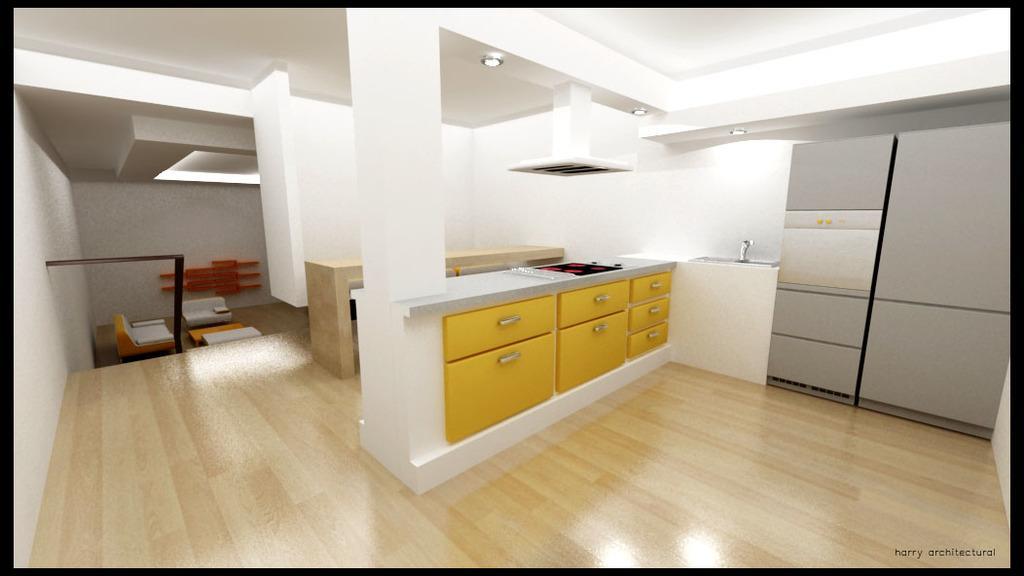Could you give a brief overview of what you see in this image? This picture shows inner view of a house and I can see a gas stove, wash basin and few lights to the ceiling and I can see drawers and a chimney and I can see table and sofas and text at the bottom right corner of the picture. 